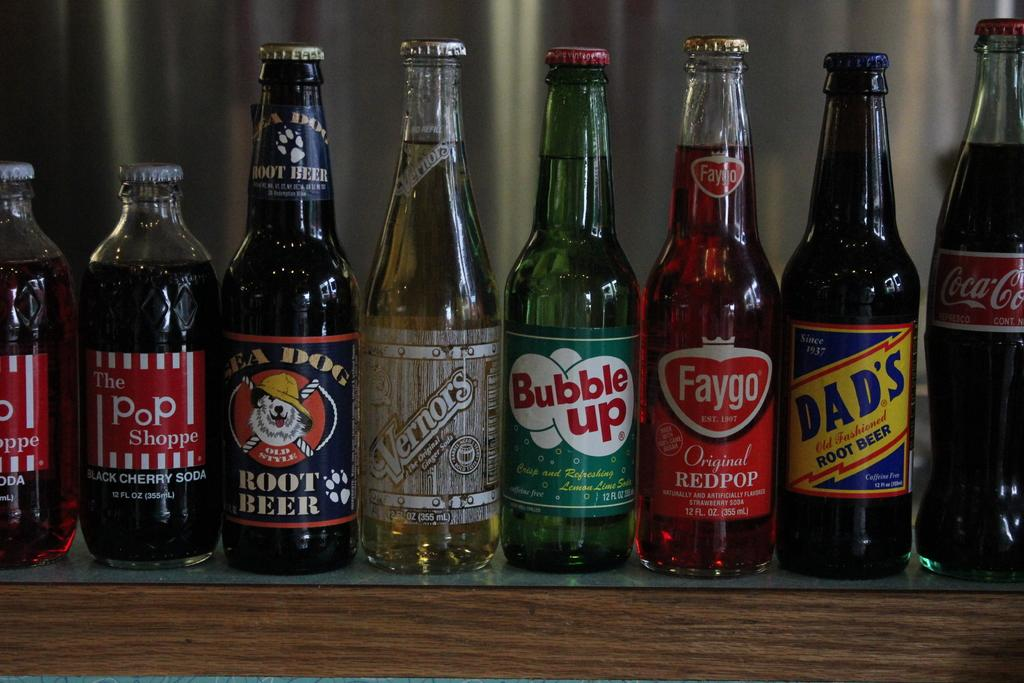<image>
Create a compact narrative representing the image presented. A bottle of Bubble Up next to several other bottles 